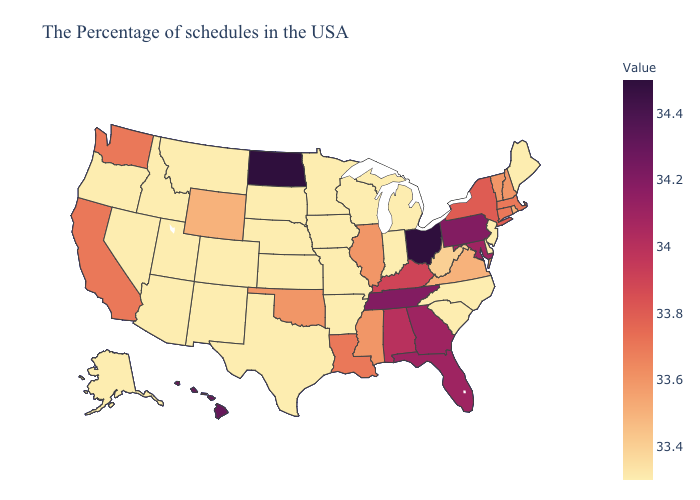Which states hav the highest value in the South?
Keep it brief. Tennessee. Does Mississippi have the lowest value in the USA?
Write a very short answer. No. Does South Carolina have the highest value in the South?
Write a very short answer. No. Does New Hampshire have the highest value in the USA?
Answer briefly. No. 